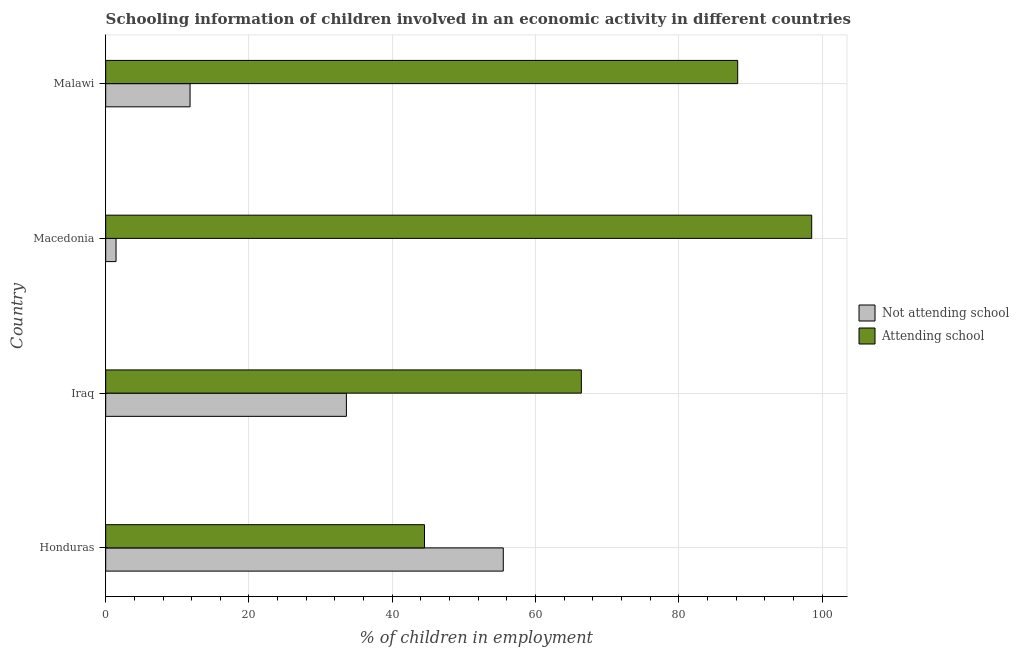How many groups of bars are there?
Provide a short and direct response. 4. Are the number of bars per tick equal to the number of legend labels?
Offer a very short reply. Yes. How many bars are there on the 1st tick from the top?
Provide a succinct answer. 2. What is the label of the 3rd group of bars from the top?
Keep it short and to the point. Iraq. What is the percentage of employed children who are attending school in Honduras?
Offer a very short reply. 44.5. Across all countries, what is the maximum percentage of employed children who are not attending school?
Offer a terse response. 55.5. Across all countries, what is the minimum percentage of employed children who are not attending school?
Provide a short and direct response. 1.45. In which country was the percentage of employed children who are attending school maximum?
Your response must be concise. Macedonia. In which country was the percentage of employed children who are not attending school minimum?
Your response must be concise. Macedonia. What is the total percentage of employed children who are not attending school in the graph?
Offer a terse response. 102.32. What is the difference between the percentage of employed children who are attending school in Macedonia and that in Malawi?
Make the answer very short. 10.33. What is the difference between the percentage of employed children who are not attending school in Iraq and the percentage of employed children who are attending school in Malawi?
Your answer should be compact. -54.62. What is the average percentage of employed children who are attending school per country?
Your answer should be compact. 74.42. What is the difference between the percentage of employed children who are attending school and percentage of employed children who are not attending school in Macedonia?
Offer a terse response. 97.11. What is the ratio of the percentage of employed children who are attending school in Honduras to that in Malawi?
Keep it short and to the point. 0.5. Is the difference between the percentage of employed children who are attending school in Iraq and Macedonia greater than the difference between the percentage of employed children who are not attending school in Iraq and Macedonia?
Your response must be concise. No. What is the difference between the highest and the second highest percentage of employed children who are not attending school?
Offer a terse response. 21.9. What is the difference between the highest and the lowest percentage of employed children who are attending school?
Your answer should be compact. 54.05. In how many countries, is the percentage of employed children who are not attending school greater than the average percentage of employed children who are not attending school taken over all countries?
Provide a succinct answer. 2. What does the 2nd bar from the top in Macedonia represents?
Offer a terse response. Not attending school. What does the 2nd bar from the bottom in Macedonia represents?
Provide a short and direct response. Attending school. How many bars are there?
Your answer should be very brief. 8. How many countries are there in the graph?
Provide a succinct answer. 4. Are the values on the major ticks of X-axis written in scientific E-notation?
Provide a succinct answer. No. Does the graph contain grids?
Make the answer very short. Yes. What is the title of the graph?
Ensure brevity in your answer.  Schooling information of children involved in an economic activity in different countries. What is the label or title of the X-axis?
Ensure brevity in your answer.  % of children in employment. What is the % of children in employment of Not attending school in Honduras?
Keep it short and to the point. 55.5. What is the % of children in employment of Attending school in Honduras?
Offer a very short reply. 44.5. What is the % of children in employment of Not attending school in Iraq?
Your answer should be compact. 33.6. What is the % of children in employment in Attending school in Iraq?
Offer a very short reply. 66.4. What is the % of children in employment of Not attending school in Macedonia?
Provide a short and direct response. 1.45. What is the % of children in employment in Attending school in Macedonia?
Provide a short and direct response. 98.55. What is the % of children in employment in Not attending school in Malawi?
Your response must be concise. 11.78. What is the % of children in employment in Attending school in Malawi?
Provide a succinct answer. 88.22. Across all countries, what is the maximum % of children in employment in Not attending school?
Keep it short and to the point. 55.5. Across all countries, what is the maximum % of children in employment of Attending school?
Your answer should be very brief. 98.55. Across all countries, what is the minimum % of children in employment in Not attending school?
Your answer should be very brief. 1.45. Across all countries, what is the minimum % of children in employment of Attending school?
Offer a terse response. 44.5. What is the total % of children in employment of Not attending school in the graph?
Make the answer very short. 102.32. What is the total % of children in employment of Attending school in the graph?
Give a very brief answer. 297.68. What is the difference between the % of children in employment of Not attending school in Honduras and that in Iraq?
Provide a succinct answer. 21.9. What is the difference between the % of children in employment in Attending school in Honduras and that in Iraq?
Ensure brevity in your answer.  -21.9. What is the difference between the % of children in employment in Not attending school in Honduras and that in Macedonia?
Provide a short and direct response. 54.05. What is the difference between the % of children in employment of Attending school in Honduras and that in Macedonia?
Offer a very short reply. -54.05. What is the difference between the % of children in employment in Not attending school in Honduras and that in Malawi?
Ensure brevity in your answer.  43.72. What is the difference between the % of children in employment in Attending school in Honduras and that in Malawi?
Ensure brevity in your answer.  -43.72. What is the difference between the % of children in employment of Not attending school in Iraq and that in Macedonia?
Your answer should be compact. 32.15. What is the difference between the % of children in employment in Attending school in Iraq and that in Macedonia?
Provide a succinct answer. -32.15. What is the difference between the % of children in employment in Not attending school in Iraq and that in Malawi?
Provide a short and direct response. 21.82. What is the difference between the % of children in employment of Attending school in Iraq and that in Malawi?
Keep it short and to the point. -21.82. What is the difference between the % of children in employment of Not attending school in Macedonia and that in Malawi?
Give a very brief answer. -10.33. What is the difference between the % of children in employment of Attending school in Macedonia and that in Malawi?
Provide a short and direct response. 10.33. What is the difference between the % of children in employment of Not attending school in Honduras and the % of children in employment of Attending school in Macedonia?
Offer a very short reply. -43.05. What is the difference between the % of children in employment in Not attending school in Honduras and the % of children in employment in Attending school in Malawi?
Make the answer very short. -32.72. What is the difference between the % of children in employment of Not attending school in Iraq and the % of children in employment of Attending school in Macedonia?
Provide a succinct answer. -64.95. What is the difference between the % of children in employment of Not attending school in Iraq and the % of children in employment of Attending school in Malawi?
Give a very brief answer. -54.62. What is the difference between the % of children in employment in Not attending school in Macedonia and the % of children in employment in Attending school in Malawi?
Offer a very short reply. -86.78. What is the average % of children in employment in Not attending school per country?
Provide a short and direct response. 25.58. What is the average % of children in employment in Attending school per country?
Provide a succinct answer. 74.42. What is the difference between the % of children in employment of Not attending school and % of children in employment of Attending school in Iraq?
Your answer should be compact. -32.8. What is the difference between the % of children in employment of Not attending school and % of children in employment of Attending school in Macedonia?
Ensure brevity in your answer.  -97.11. What is the difference between the % of children in employment of Not attending school and % of children in employment of Attending school in Malawi?
Provide a succinct answer. -76.45. What is the ratio of the % of children in employment of Not attending school in Honduras to that in Iraq?
Provide a succinct answer. 1.65. What is the ratio of the % of children in employment in Attending school in Honduras to that in Iraq?
Your answer should be very brief. 0.67. What is the ratio of the % of children in employment of Not attending school in Honduras to that in Macedonia?
Ensure brevity in your answer.  38.4. What is the ratio of the % of children in employment in Attending school in Honduras to that in Macedonia?
Offer a terse response. 0.45. What is the ratio of the % of children in employment of Not attending school in Honduras to that in Malawi?
Your answer should be compact. 4.71. What is the ratio of the % of children in employment in Attending school in Honduras to that in Malawi?
Your answer should be very brief. 0.5. What is the ratio of the % of children in employment in Not attending school in Iraq to that in Macedonia?
Give a very brief answer. 23.25. What is the ratio of the % of children in employment of Attending school in Iraq to that in Macedonia?
Offer a very short reply. 0.67. What is the ratio of the % of children in employment of Not attending school in Iraq to that in Malawi?
Offer a terse response. 2.85. What is the ratio of the % of children in employment of Attending school in Iraq to that in Malawi?
Offer a very short reply. 0.75. What is the ratio of the % of children in employment in Not attending school in Macedonia to that in Malawi?
Ensure brevity in your answer.  0.12. What is the ratio of the % of children in employment of Attending school in Macedonia to that in Malawi?
Provide a succinct answer. 1.12. What is the difference between the highest and the second highest % of children in employment in Not attending school?
Your answer should be very brief. 21.9. What is the difference between the highest and the second highest % of children in employment in Attending school?
Keep it short and to the point. 10.33. What is the difference between the highest and the lowest % of children in employment of Not attending school?
Keep it short and to the point. 54.05. What is the difference between the highest and the lowest % of children in employment of Attending school?
Provide a succinct answer. 54.05. 